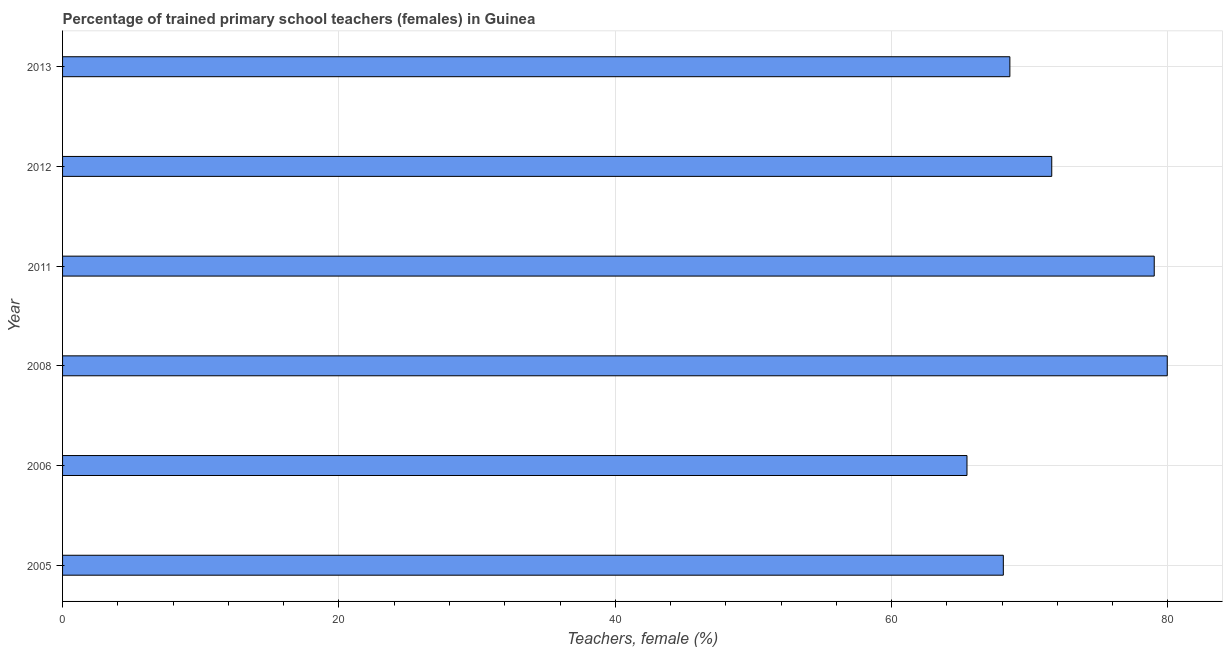Does the graph contain grids?
Give a very brief answer. Yes. What is the title of the graph?
Offer a very short reply. Percentage of trained primary school teachers (females) in Guinea. What is the label or title of the X-axis?
Give a very brief answer. Teachers, female (%). What is the percentage of trained female teachers in 2013?
Your answer should be compact. 68.56. Across all years, what is the maximum percentage of trained female teachers?
Your answer should be very brief. 79.95. Across all years, what is the minimum percentage of trained female teachers?
Offer a very short reply. 65.45. In which year was the percentage of trained female teachers minimum?
Provide a succinct answer. 2006. What is the sum of the percentage of trained female teachers?
Offer a very short reply. 432.64. What is the difference between the percentage of trained female teachers in 2008 and 2011?
Ensure brevity in your answer.  0.94. What is the average percentage of trained female teachers per year?
Your answer should be compact. 72.11. What is the median percentage of trained female teachers?
Your response must be concise. 70.07. In how many years, is the percentage of trained female teachers greater than 20 %?
Provide a short and direct response. 6. What is the ratio of the percentage of trained female teachers in 2008 to that in 2012?
Your answer should be compact. 1.12. Is the difference between the percentage of trained female teachers in 2008 and 2012 greater than the difference between any two years?
Offer a terse response. No. What is the difference between the highest and the second highest percentage of trained female teachers?
Offer a very short reply. 0.94. Is the sum of the percentage of trained female teachers in 2011 and 2013 greater than the maximum percentage of trained female teachers across all years?
Keep it short and to the point. Yes. What is the difference between the highest and the lowest percentage of trained female teachers?
Provide a succinct answer. 14.49. Are all the bars in the graph horizontal?
Provide a succinct answer. Yes. What is the difference between two consecutive major ticks on the X-axis?
Give a very brief answer. 20. Are the values on the major ticks of X-axis written in scientific E-notation?
Your answer should be compact. No. What is the Teachers, female (%) in 2005?
Give a very brief answer. 68.08. What is the Teachers, female (%) in 2006?
Your answer should be very brief. 65.45. What is the Teachers, female (%) in 2008?
Offer a terse response. 79.95. What is the Teachers, female (%) in 2011?
Keep it short and to the point. 79.01. What is the Teachers, female (%) of 2012?
Make the answer very short. 71.59. What is the Teachers, female (%) of 2013?
Your response must be concise. 68.56. What is the difference between the Teachers, female (%) in 2005 and 2006?
Make the answer very short. 2.63. What is the difference between the Teachers, female (%) in 2005 and 2008?
Ensure brevity in your answer.  -11.86. What is the difference between the Teachers, female (%) in 2005 and 2011?
Provide a short and direct response. -10.92. What is the difference between the Teachers, female (%) in 2005 and 2012?
Provide a short and direct response. -3.5. What is the difference between the Teachers, female (%) in 2005 and 2013?
Your response must be concise. -0.47. What is the difference between the Teachers, female (%) in 2006 and 2008?
Offer a very short reply. -14.49. What is the difference between the Teachers, female (%) in 2006 and 2011?
Make the answer very short. -13.55. What is the difference between the Teachers, female (%) in 2006 and 2012?
Provide a short and direct response. -6.14. What is the difference between the Teachers, female (%) in 2006 and 2013?
Keep it short and to the point. -3.1. What is the difference between the Teachers, female (%) in 2008 and 2011?
Your answer should be very brief. 0.94. What is the difference between the Teachers, female (%) in 2008 and 2012?
Ensure brevity in your answer.  8.36. What is the difference between the Teachers, female (%) in 2008 and 2013?
Make the answer very short. 11.39. What is the difference between the Teachers, female (%) in 2011 and 2012?
Provide a succinct answer. 7.42. What is the difference between the Teachers, female (%) in 2011 and 2013?
Your response must be concise. 10.45. What is the difference between the Teachers, female (%) in 2012 and 2013?
Your response must be concise. 3.03. What is the ratio of the Teachers, female (%) in 2005 to that in 2006?
Offer a very short reply. 1.04. What is the ratio of the Teachers, female (%) in 2005 to that in 2008?
Offer a very short reply. 0.85. What is the ratio of the Teachers, female (%) in 2005 to that in 2011?
Give a very brief answer. 0.86. What is the ratio of the Teachers, female (%) in 2005 to that in 2012?
Provide a short and direct response. 0.95. What is the ratio of the Teachers, female (%) in 2006 to that in 2008?
Offer a very short reply. 0.82. What is the ratio of the Teachers, female (%) in 2006 to that in 2011?
Your answer should be compact. 0.83. What is the ratio of the Teachers, female (%) in 2006 to that in 2012?
Provide a short and direct response. 0.91. What is the ratio of the Teachers, female (%) in 2006 to that in 2013?
Your answer should be compact. 0.95. What is the ratio of the Teachers, female (%) in 2008 to that in 2012?
Provide a succinct answer. 1.12. What is the ratio of the Teachers, female (%) in 2008 to that in 2013?
Ensure brevity in your answer.  1.17. What is the ratio of the Teachers, female (%) in 2011 to that in 2012?
Provide a short and direct response. 1.1. What is the ratio of the Teachers, female (%) in 2011 to that in 2013?
Offer a terse response. 1.15. What is the ratio of the Teachers, female (%) in 2012 to that in 2013?
Give a very brief answer. 1.04. 